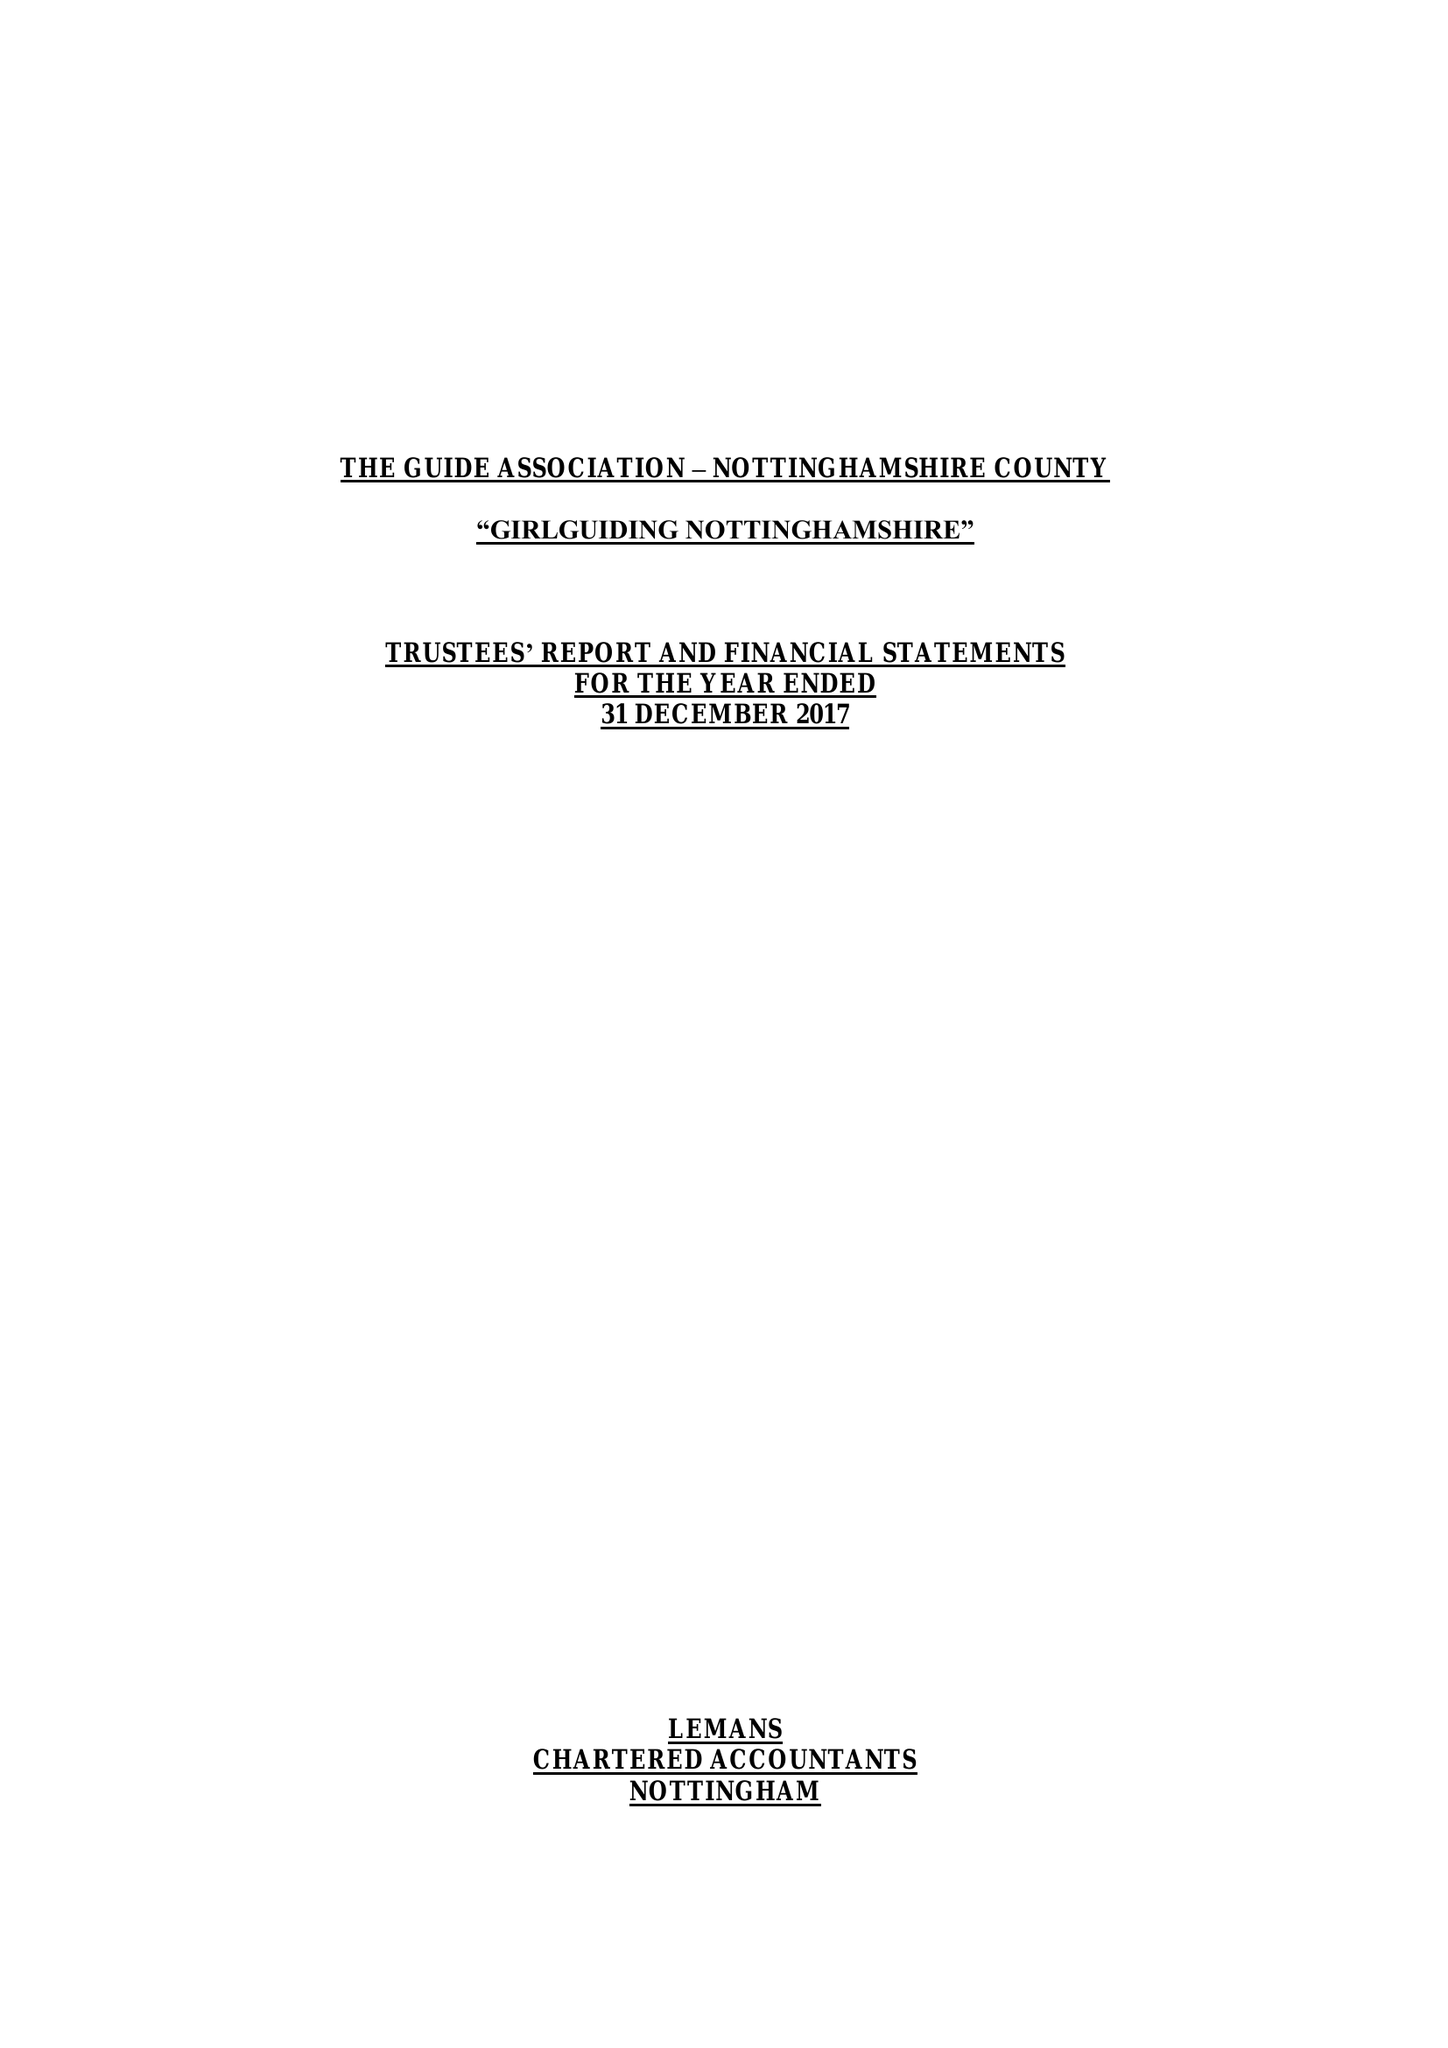What is the value for the charity_name?
Answer the question using a single word or phrase. The Guide Association - Nottinghamshire County 